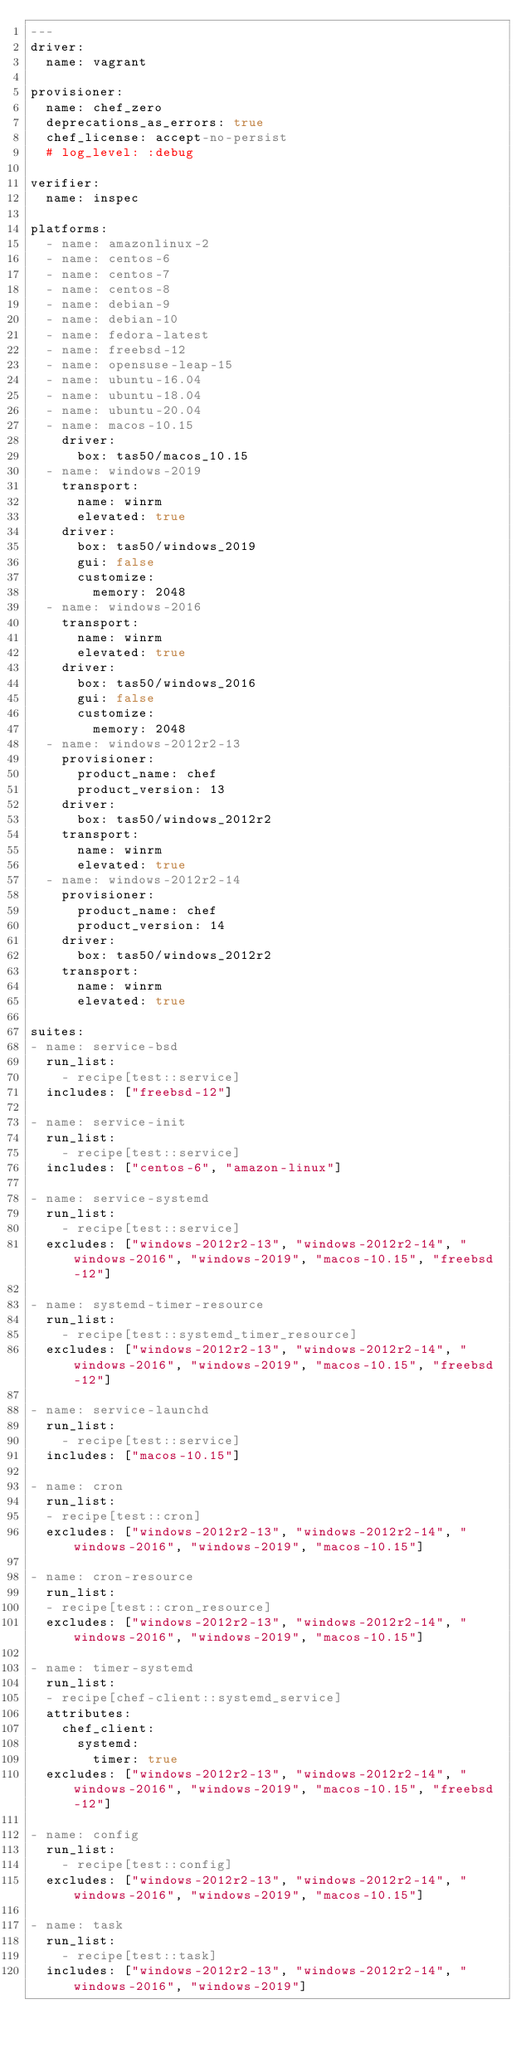Convert code to text. <code><loc_0><loc_0><loc_500><loc_500><_YAML_>---
driver:
  name: vagrant

provisioner:
  name: chef_zero
  deprecations_as_errors: true
  chef_license: accept-no-persist
  # log_level: :debug

verifier:
  name: inspec

platforms:
  - name: amazonlinux-2
  - name: centos-6
  - name: centos-7
  - name: centos-8
  - name: debian-9
  - name: debian-10
  - name: fedora-latest
  - name: freebsd-12
  - name: opensuse-leap-15
  - name: ubuntu-16.04
  - name: ubuntu-18.04
  - name: ubuntu-20.04
  - name: macos-10.15
    driver:
      box: tas50/macos_10.15
  - name: windows-2019
    transport:
      name: winrm
      elevated: true
    driver:
      box: tas50/windows_2019
      gui: false
      customize:
        memory: 2048
  - name: windows-2016
    transport:
      name: winrm
      elevated: true
    driver:
      box: tas50/windows_2016
      gui: false
      customize:
        memory: 2048
  - name: windows-2012r2-13
    provisioner:
      product_name: chef
      product_version: 13
    driver:
      box: tas50/windows_2012r2
    transport:
      name: winrm
      elevated: true
  - name: windows-2012r2-14
    provisioner:
      product_name: chef
      product_version: 14
    driver:
      box: tas50/windows_2012r2
    transport:
      name: winrm
      elevated: true

suites:
- name: service-bsd
  run_list:
    - recipe[test::service]
  includes: ["freebsd-12"]

- name: service-init
  run_list:
    - recipe[test::service]
  includes: ["centos-6", "amazon-linux"]

- name: service-systemd
  run_list:
    - recipe[test::service]
  excludes: ["windows-2012r2-13", "windows-2012r2-14", "windows-2016", "windows-2019", "macos-10.15", "freebsd-12"]

- name: systemd-timer-resource
  run_list:
    - recipe[test::systemd_timer_resource]
  excludes: ["windows-2012r2-13", "windows-2012r2-14", "windows-2016", "windows-2019", "macos-10.15", "freebsd-12"]

- name: service-launchd
  run_list:
    - recipe[test::service]
  includes: ["macos-10.15"]

- name: cron
  run_list:
  - recipe[test::cron]
  excludes: ["windows-2012r2-13", "windows-2012r2-14", "windows-2016", "windows-2019", "macos-10.15"]

- name: cron-resource
  run_list:
  - recipe[test::cron_resource]
  excludes: ["windows-2012r2-13", "windows-2012r2-14", "windows-2016", "windows-2019", "macos-10.15"]

- name: timer-systemd
  run_list:
  - recipe[chef-client::systemd_service]
  attributes:
    chef_client:
      systemd:
        timer: true
  excludes: ["windows-2012r2-13", "windows-2012r2-14", "windows-2016", "windows-2019", "macos-10.15", "freebsd-12"]

- name: config
  run_list:
    - recipe[test::config]
  excludes: ["windows-2012r2-13", "windows-2012r2-14", "windows-2016", "windows-2019", "macos-10.15"]

- name: task
  run_list:
    - recipe[test::task]
  includes: ["windows-2012r2-13", "windows-2012r2-14", "windows-2016", "windows-2019"]
</code> 